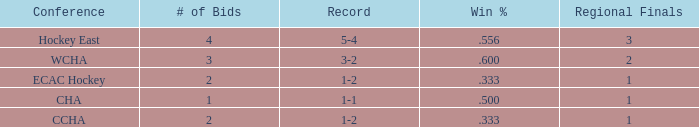What is the average Regional Finals score when the record is 3-2 and there are more than 3 bids? None. 